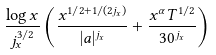<formula> <loc_0><loc_0><loc_500><loc_500>\frac { \log x } { j _ { x } ^ { 3 / 2 } } \left ( \frac { x ^ { 1 / 2 + 1 / ( 2 j _ { x } ) } } { | a | ^ { j _ { x } } } + \frac { x ^ { \alpha } T ^ { 1 / 2 } } { 3 0 ^ { j _ { x } } } \right )</formula> 